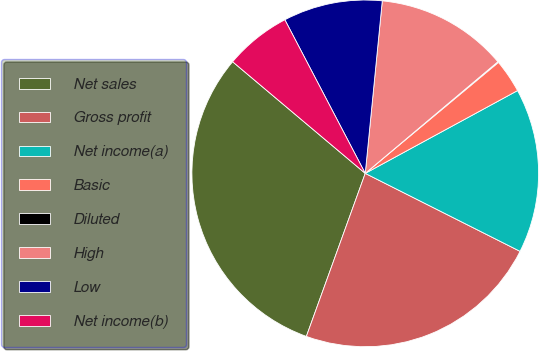Convert chart. <chart><loc_0><loc_0><loc_500><loc_500><pie_chart><fcel>Net sales<fcel>Gross profit<fcel>Net income(a)<fcel>Basic<fcel>Diluted<fcel>High<fcel>Low<fcel>Net income(b)<nl><fcel>30.62%<fcel>23.09%<fcel>15.35%<fcel>3.13%<fcel>0.08%<fcel>12.3%<fcel>9.24%<fcel>6.19%<nl></chart> 